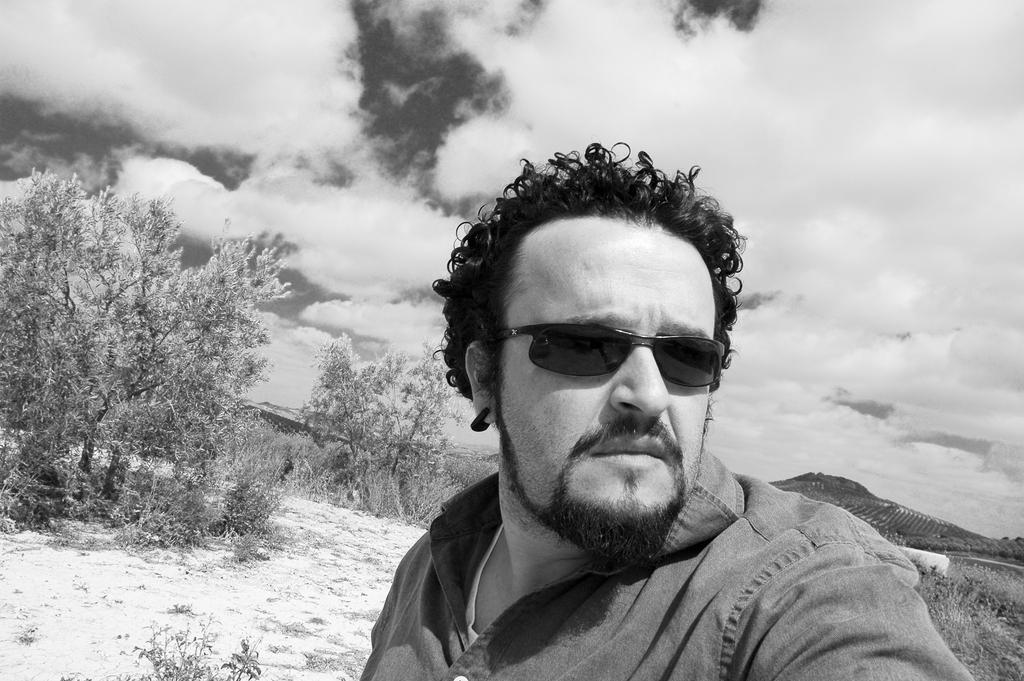How would you summarize this image in a sentence or two? This is a black and white picture. Here, we see the man who is wearing goggles is standing. Behind him, there are trees. In the background, we see the hill. At the top of the picture, we see the sky and the clouds. 